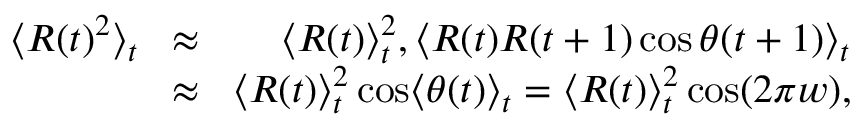Convert formula to latex. <formula><loc_0><loc_0><loc_500><loc_500>\begin{array} { r l r } { \langle R ( t ) ^ { 2 } \rangle _ { t } \, } & { \approx } & { \, \langle R ( t ) \rangle _ { t } ^ { 2 } , \langle R ( t ) R ( t + 1 ) \cos \theta ( t + 1 ) \rangle _ { t } } \\ { \, } & { \approx } & { \, \langle R ( t ) \rangle _ { t } ^ { 2 } \cos \langle \theta ( t ) \rangle _ { t } = \langle R ( t ) \rangle _ { t } ^ { 2 } \cos ( 2 \pi w ) , } \end{array}</formula> 